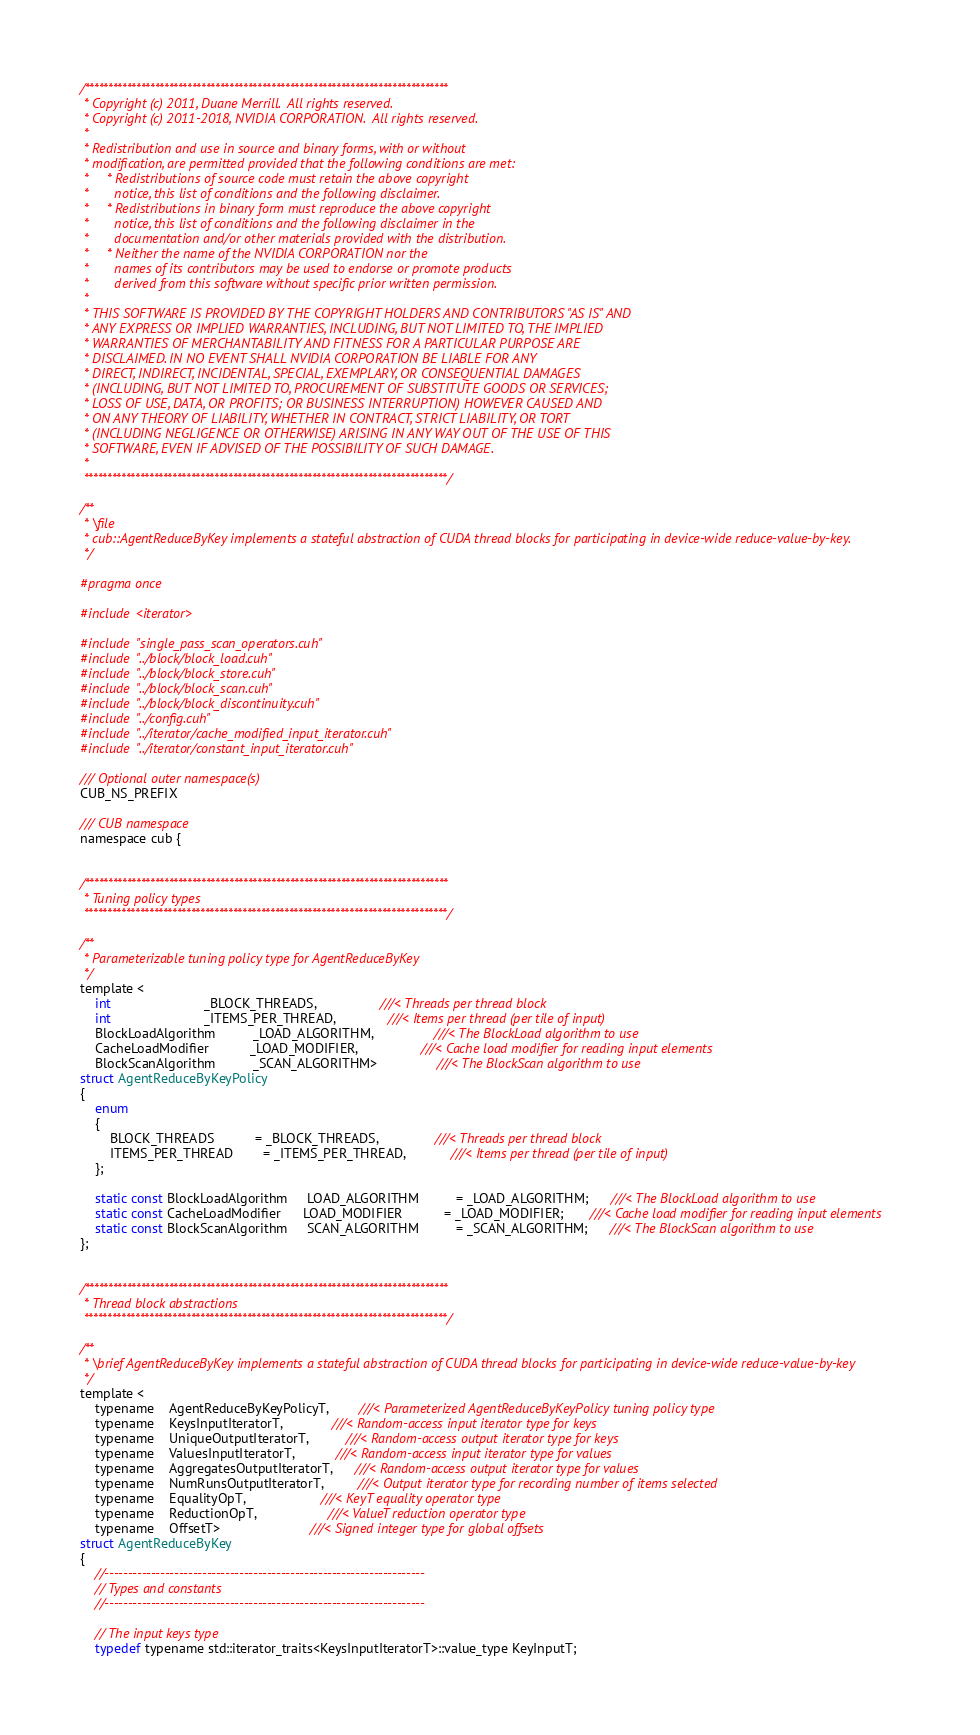<code> <loc_0><loc_0><loc_500><loc_500><_Cuda_>/******************************************************************************
 * Copyright (c) 2011, Duane Merrill.  All rights reserved.
 * Copyright (c) 2011-2018, NVIDIA CORPORATION.  All rights reserved.
 *
 * Redistribution and use in source and binary forms, with or without
 * modification, are permitted provided that the following conditions are met:
 *     * Redistributions of source code must retain the above copyright
 *       notice, this list of conditions and the following disclaimer.
 *     * Redistributions in binary form must reproduce the above copyright
 *       notice, this list of conditions and the following disclaimer in the
 *       documentation and/or other materials provided with the distribution.
 *     * Neither the name of the NVIDIA CORPORATION nor the
 *       names of its contributors may be used to endorse or promote products
 *       derived from this software without specific prior written permission.
 *
 * THIS SOFTWARE IS PROVIDED BY THE COPYRIGHT HOLDERS AND CONTRIBUTORS "AS IS" AND
 * ANY EXPRESS OR IMPLIED WARRANTIES, INCLUDING, BUT NOT LIMITED TO, THE IMPLIED
 * WARRANTIES OF MERCHANTABILITY AND FITNESS FOR A PARTICULAR PURPOSE ARE
 * DISCLAIMED. IN NO EVENT SHALL NVIDIA CORPORATION BE LIABLE FOR ANY
 * DIRECT, INDIRECT, INCIDENTAL, SPECIAL, EXEMPLARY, OR CONSEQUENTIAL DAMAGES
 * (INCLUDING, BUT NOT LIMITED TO, PROCUREMENT OF SUBSTITUTE GOODS OR SERVICES;
 * LOSS OF USE, DATA, OR PROFITS; OR BUSINESS INTERRUPTION) HOWEVER CAUSED AND
 * ON ANY THEORY OF LIABILITY, WHETHER IN CONTRACT, STRICT LIABILITY, OR TORT
 * (INCLUDING NEGLIGENCE OR OTHERWISE) ARISING IN ANY WAY OUT OF THE USE OF THIS
 * SOFTWARE, EVEN IF ADVISED OF THE POSSIBILITY OF SUCH DAMAGE.
 *
 ******************************************************************************/

/**
 * \file
 * cub::AgentReduceByKey implements a stateful abstraction of CUDA thread blocks for participating in device-wide reduce-value-by-key.
 */

#pragma once

#include <iterator>

#include "single_pass_scan_operators.cuh"
#include "../block/block_load.cuh"
#include "../block/block_store.cuh"
#include "../block/block_scan.cuh"
#include "../block/block_discontinuity.cuh"
#include "../config.cuh"
#include "../iterator/cache_modified_input_iterator.cuh"
#include "../iterator/constant_input_iterator.cuh"

/// Optional outer namespace(s)
CUB_NS_PREFIX

/// CUB namespace
namespace cub {


/******************************************************************************
 * Tuning policy types
 ******************************************************************************/

/**
 * Parameterizable tuning policy type for AgentReduceByKey
 */
template <
    int                         _BLOCK_THREADS,                 ///< Threads per thread block
    int                         _ITEMS_PER_THREAD,              ///< Items per thread (per tile of input)
    BlockLoadAlgorithm          _LOAD_ALGORITHM,                ///< The BlockLoad algorithm to use
    CacheLoadModifier           _LOAD_MODIFIER,                 ///< Cache load modifier for reading input elements
    BlockScanAlgorithm          _SCAN_ALGORITHM>                ///< The BlockScan algorithm to use
struct AgentReduceByKeyPolicy
{
    enum
    {
        BLOCK_THREADS           = _BLOCK_THREADS,               ///< Threads per thread block
        ITEMS_PER_THREAD        = _ITEMS_PER_THREAD,            ///< Items per thread (per tile of input)
    };

    static const BlockLoadAlgorithm     LOAD_ALGORITHM          = _LOAD_ALGORITHM;      ///< The BlockLoad algorithm to use
    static const CacheLoadModifier      LOAD_MODIFIER           = _LOAD_MODIFIER;       ///< Cache load modifier for reading input elements
    static const BlockScanAlgorithm     SCAN_ALGORITHM          = _SCAN_ALGORITHM;      ///< The BlockScan algorithm to use
};


/******************************************************************************
 * Thread block abstractions
 ******************************************************************************/

/**
 * \brief AgentReduceByKey implements a stateful abstraction of CUDA thread blocks for participating in device-wide reduce-value-by-key
 */
template <
    typename    AgentReduceByKeyPolicyT,        ///< Parameterized AgentReduceByKeyPolicy tuning policy type
    typename    KeysInputIteratorT,             ///< Random-access input iterator type for keys
    typename    UniqueOutputIteratorT,          ///< Random-access output iterator type for keys
    typename    ValuesInputIteratorT,           ///< Random-access input iterator type for values
    typename    AggregatesOutputIteratorT,      ///< Random-access output iterator type for values
    typename    NumRunsOutputIteratorT,         ///< Output iterator type for recording number of items selected
    typename    EqualityOpT,                    ///< KeyT equality operator type
    typename    ReductionOpT,                   ///< ValueT reduction operator type
    typename    OffsetT>                        ///< Signed integer type for global offsets
struct AgentReduceByKey
{
    //---------------------------------------------------------------------
    // Types and constants
    //---------------------------------------------------------------------

    // The input keys type
    typedef typename std::iterator_traits<KeysInputIteratorT>::value_type KeyInputT;
</code> 